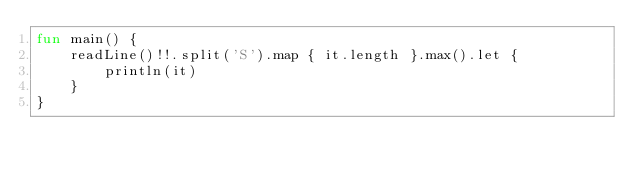<code> <loc_0><loc_0><loc_500><loc_500><_Kotlin_>fun main() {
    readLine()!!.split('S').map { it.length }.max().let {
        println(it)
    }
}
</code> 